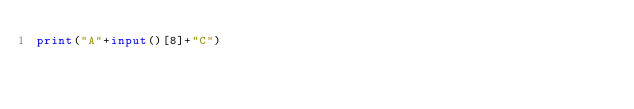<code> <loc_0><loc_0><loc_500><loc_500><_Python_>print("A"+input()[8]+"C")</code> 